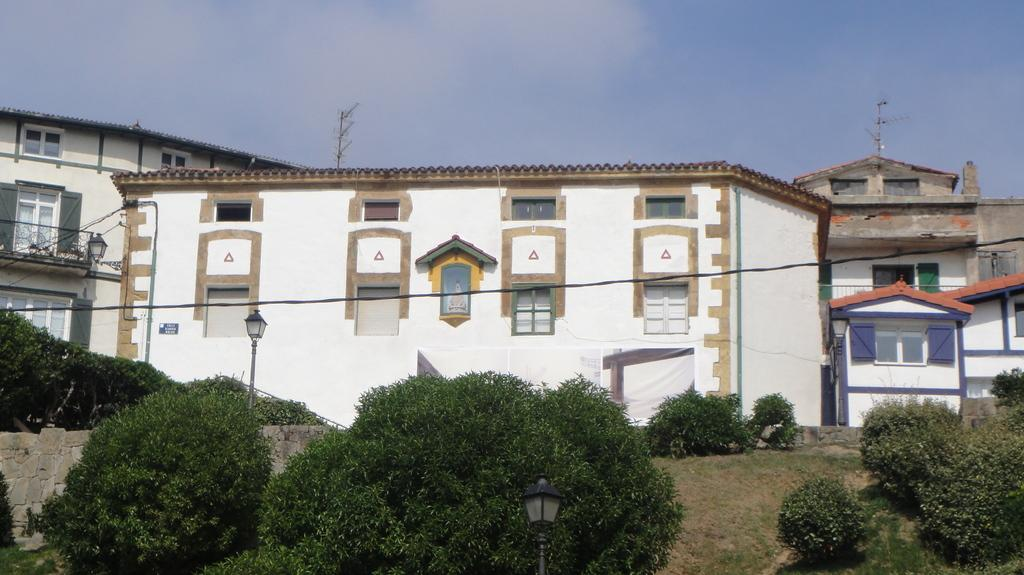What type of vegetation can be seen in the image? There are shrubs in the image. What structures are present in the image? There are light poles, a stone wall, and buildings in the image. What type of ground cover is visible in the image? There is grass in the image. What can be seen in the sky in the background of the image? The sky in the background is cloudy. What type of needle is being used to sew the reaction in the image? There is no needle or reaction present in the image. What type of addition is being made to the stone wall in the image? There is no addition being made to the stone wall in the image. 